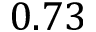Convert formula to latex. <formula><loc_0><loc_0><loc_500><loc_500>0 . 7 3</formula> 